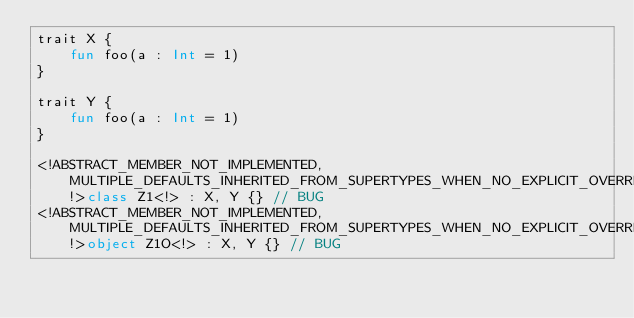Convert code to text. <code><loc_0><loc_0><loc_500><loc_500><_Kotlin_>trait X {
    fun foo(a : Int = 1)
}

trait Y {
    fun foo(a : Int = 1)
}

<!ABSTRACT_MEMBER_NOT_IMPLEMENTED, MULTIPLE_DEFAULTS_INHERITED_FROM_SUPERTYPES_WHEN_NO_EXPLICIT_OVERRIDE!>class Z1<!> : X, Y {} // BUG
<!ABSTRACT_MEMBER_NOT_IMPLEMENTED, MULTIPLE_DEFAULTS_INHERITED_FROM_SUPERTYPES_WHEN_NO_EXPLICIT_OVERRIDE!>object Z1O<!> : X, Y {} // BUG</code> 